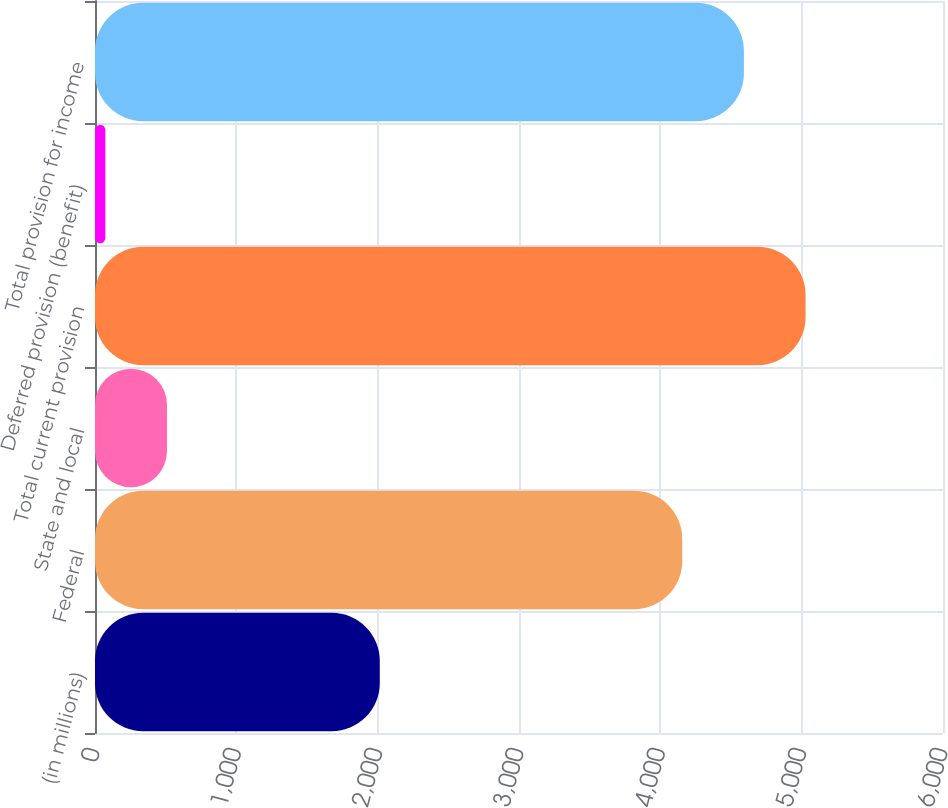Convert chart. <chart><loc_0><loc_0><loc_500><loc_500><bar_chart><fcel>(in millions)<fcel>Federal<fcel>State and local<fcel>Total current provision<fcel>Deferred provision (benefit)<fcel>Total provision for income<nl><fcel>2015<fcel>4155<fcel>509.3<fcel>5027.6<fcel>73<fcel>4591.3<nl></chart> 